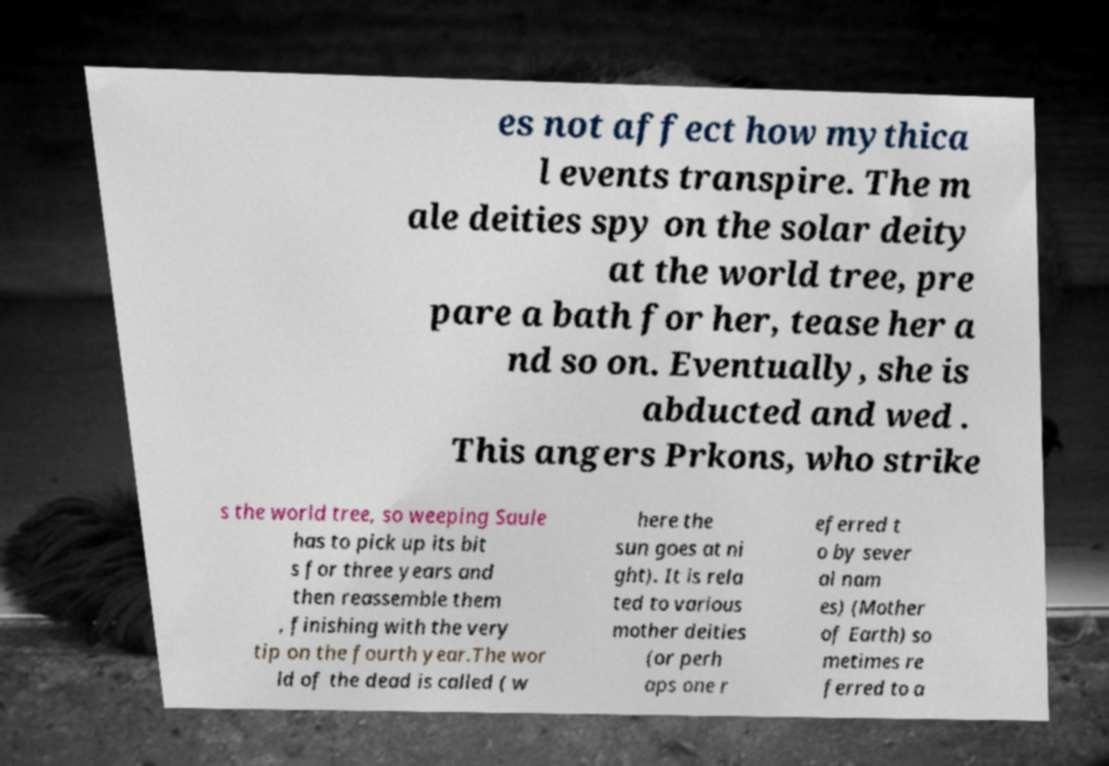I need the written content from this picture converted into text. Can you do that? es not affect how mythica l events transpire. The m ale deities spy on the solar deity at the world tree, pre pare a bath for her, tease her a nd so on. Eventually, she is abducted and wed . This angers Prkons, who strike s the world tree, so weeping Saule has to pick up its bit s for three years and then reassemble them , finishing with the very tip on the fourth year.The wor ld of the dead is called ( w here the sun goes at ni ght). It is rela ted to various mother deities (or perh aps one r eferred t o by sever al nam es) (Mother of Earth) so metimes re ferred to a 